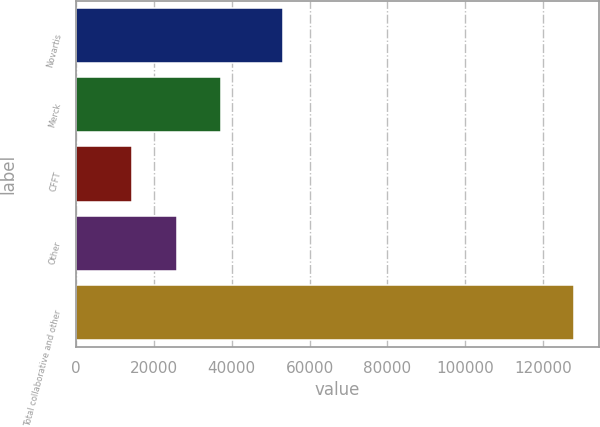Convert chart to OTSL. <chart><loc_0><loc_0><loc_500><loc_500><bar_chart><fcel>Novartis<fcel>Merck<fcel>CFFT<fcel>Other<fcel>Total collaborative and other<nl><fcel>53082<fcel>37204.2<fcel>14490<fcel>25847.1<fcel>128061<nl></chart> 